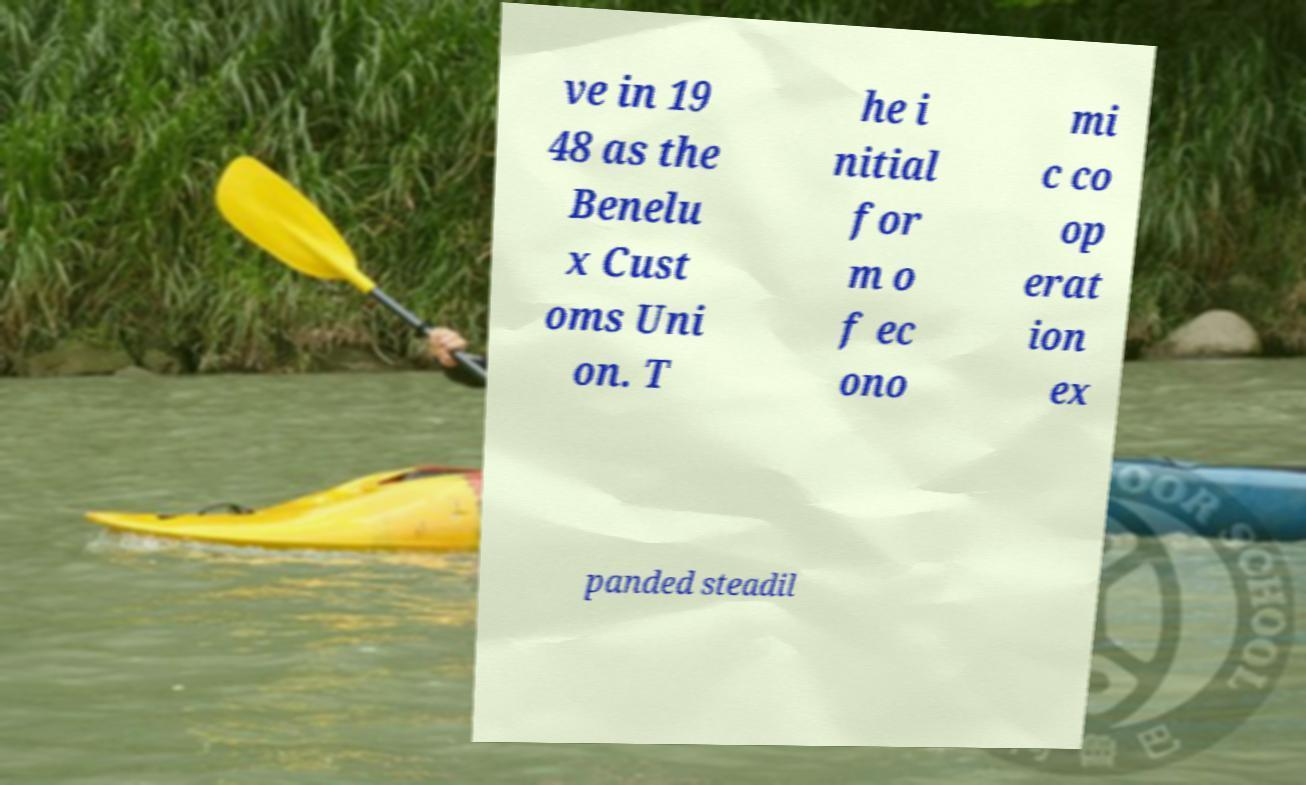Could you assist in decoding the text presented in this image and type it out clearly? ve in 19 48 as the Benelu x Cust oms Uni on. T he i nitial for m o f ec ono mi c co op erat ion ex panded steadil 